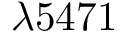Convert formula to latex. <formula><loc_0><loc_0><loc_500><loc_500>\lambda 5 4 7 1</formula> 